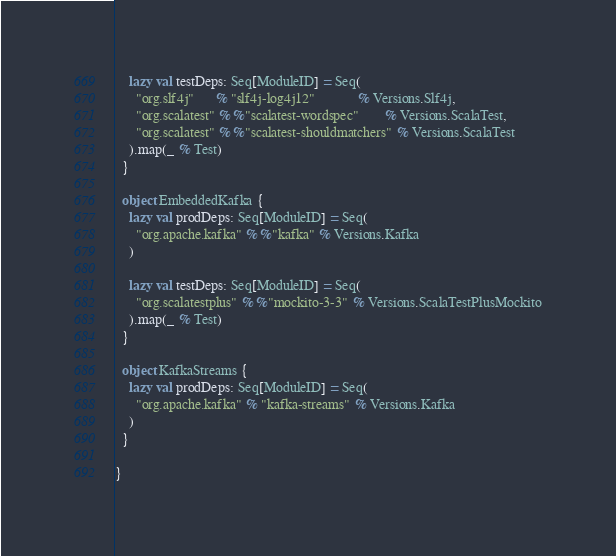Convert code to text. <code><loc_0><loc_0><loc_500><loc_500><_Scala_>    lazy val testDeps: Seq[ModuleID] = Seq(
      "org.slf4j"      % "slf4j-log4j12"            % Versions.Slf4j,
      "org.scalatest" %% "scalatest-wordspec"       % Versions.ScalaTest,
      "org.scalatest" %% "scalatest-shouldmatchers" % Versions.ScalaTest
    ).map(_ % Test)
  }

  object EmbeddedKafka {
    lazy val prodDeps: Seq[ModuleID] = Seq(
      "org.apache.kafka" %% "kafka" % Versions.Kafka
    )

    lazy val testDeps: Seq[ModuleID] = Seq(
      "org.scalatestplus" %% "mockito-3-3" % Versions.ScalaTestPlusMockito
    ).map(_ % Test)
  }

  object KafkaStreams {
    lazy val prodDeps: Seq[ModuleID] = Seq(
      "org.apache.kafka" % "kafka-streams" % Versions.Kafka
    )
  }

}
</code> 